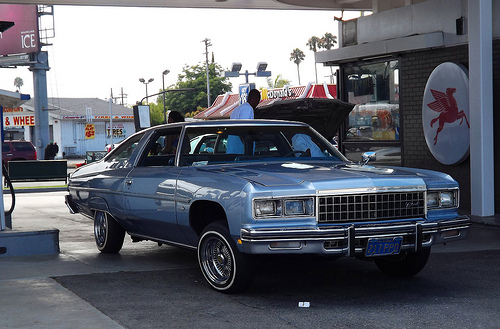<image>
Is the man to the left of the car? Yes. From this viewpoint, the man is positioned to the left side relative to the car. 